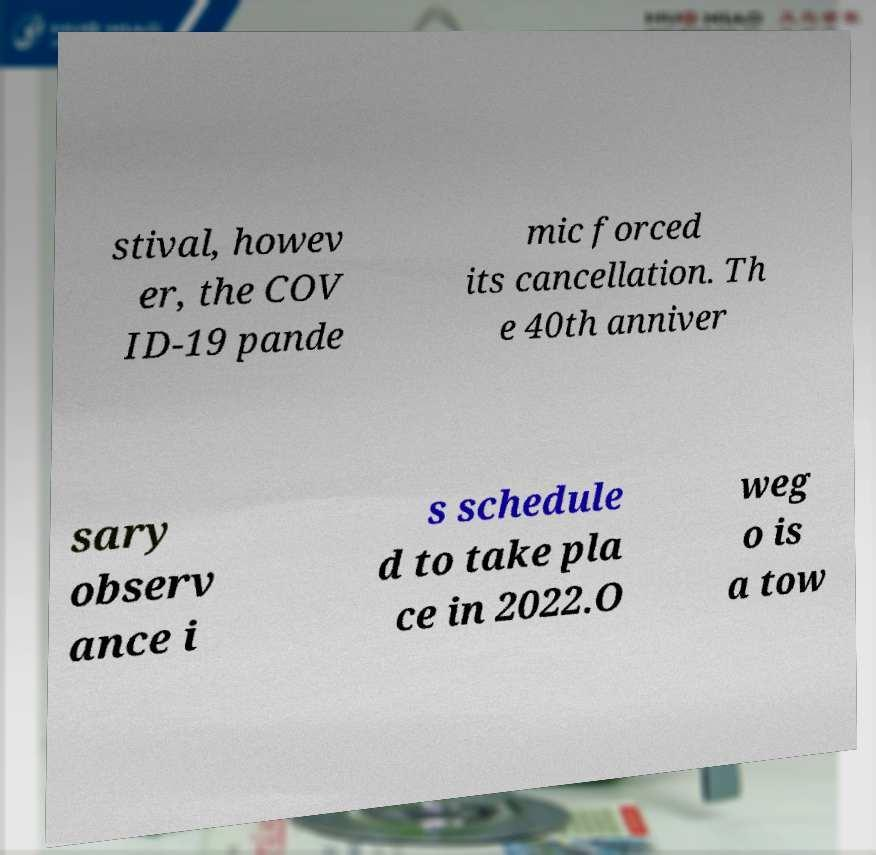Please identify and transcribe the text found in this image. stival, howev er, the COV ID-19 pande mic forced its cancellation. Th e 40th anniver sary observ ance i s schedule d to take pla ce in 2022.O weg o is a tow 